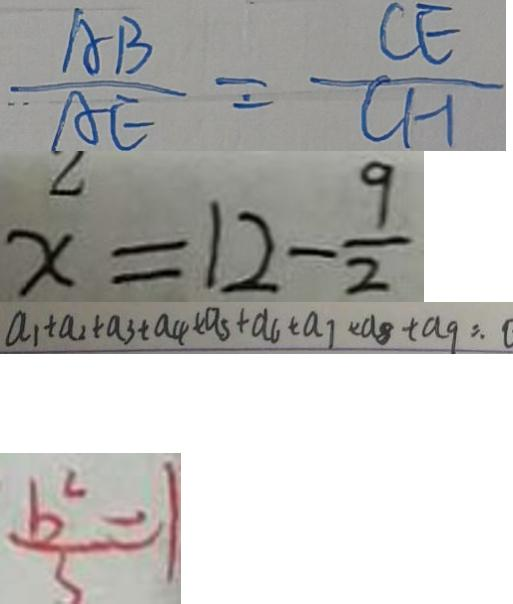Convert formula to latex. <formula><loc_0><loc_0><loc_500><loc_500>\frac { A B } { A E } = \frac { C E } { C H } 
 x = 1 2 - \frac { 9 } { 2 } 
 a _ { 1 } + a _ { 2 } + a _ { 3 } + a _ { 4 } + a _ { 5 } + a _ { 6 } + a _ { 7 } + a _ { 8 } + a _ { 9 } = . 0 
 \frac { b ^ { 2 } } { 5 } = 1</formula> 